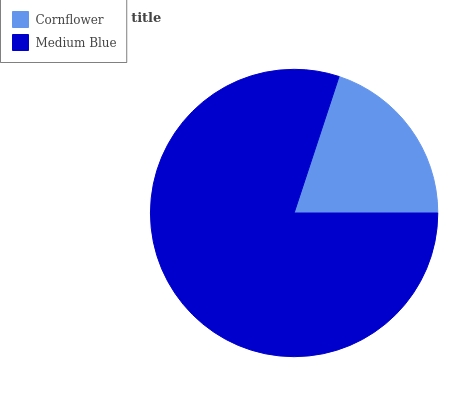Is Cornflower the minimum?
Answer yes or no. Yes. Is Medium Blue the maximum?
Answer yes or no. Yes. Is Medium Blue the minimum?
Answer yes or no. No. Is Medium Blue greater than Cornflower?
Answer yes or no. Yes. Is Cornflower less than Medium Blue?
Answer yes or no. Yes. Is Cornflower greater than Medium Blue?
Answer yes or no. No. Is Medium Blue less than Cornflower?
Answer yes or no. No. Is Medium Blue the high median?
Answer yes or no. Yes. Is Cornflower the low median?
Answer yes or no. Yes. Is Cornflower the high median?
Answer yes or no. No. Is Medium Blue the low median?
Answer yes or no. No. 